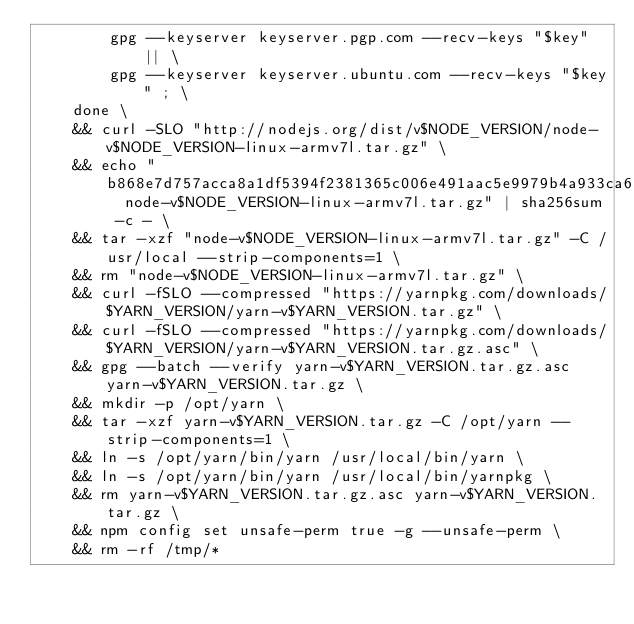<code> <loc_0><loc_0><loc_500><loc_500><_Dockerfile_>		gpg --keyserver keyserver.pgp.com --recv-keys "$key" || \
		gpg --keyserver keyserver.ubuntu.com --recv-keys "$key" ; \
	done \
	&& curl -SLO "http://nodejs.org/dist/v$NODE_VERSION/node-v$NODE_VERSION-linux-armv7l.tar.gz" \
	&& echo "b868e7d757acca8a1df5394f2381365c006e491aac5e9979b4a933ca66698f8c  node-v$NODE_VERSION-linux-armv7l.tar.gz" | sha256sum -c - \
	&& tar -xzf "node-v$NODE_VERSION-linux-armv7l.tar.gz" -C /usr/local --strip-components=1 \
	&& rm "node-v$NODE_VERSION-linux-armv7l.tar.gz" \
	&& curl -fSLO --compressed "https://yarnpkg.com/downloads/$YARN_VERSION/yarn-v$YARN_VERSION.tar.gz" \
	&& curl -fSLO --compressed "https://yarnpkg.com/downloads/$YARN_VERSION/yarn-v$YARN_VERSION.tar.gz.asc" \
	&& gpg --batch --verify yarn-v$YARN_VERSION.tar.gz.asc yarn-v$YARN_VERSION.tar.gz \
	&& mkdir -p /opt/yarn \
	&& tar -xzf yarn-v$YARN_VERSION.tar.gz -C /opt/yarn --strip-components=1 \
	&& ln -s /opt/yarn/bin/yarn /usr/local/bin/yarn \
	&& ln -s /opt/yarn/bin/yarn /usr/local/bin/yarnpkg \
	&& rm yarn-v$YARN_VERSION.tar.gz.asc yarn-v$YARN_VERSION.tar.gz \
	&& npm config set unsafe-perm true -g --unsafe-perm \
	&& rm -rf /tmp/*
</code> 